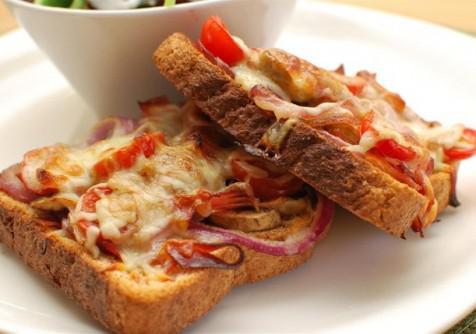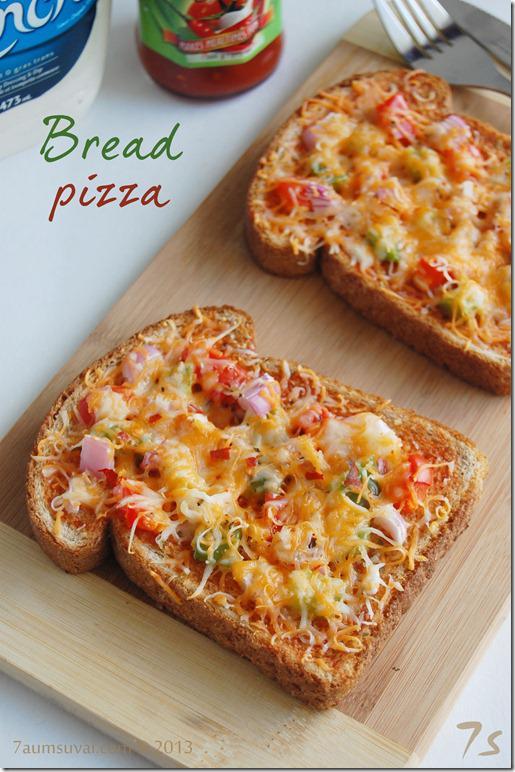The first image is the image on the left, the second image is the image on the right. Evaluate the accuracy of this statement regarding the images: "All pizzas are made on pieces of bread". Is it true? Answer yes or no. Yes. The first image is the image on the left, the second image is the image on the right. Analyze the images presented: Is the assertion "The left image shows a round pizza cut into slices on a wooden board, and the right image shows rectangles of pizza." valid? Answer yes or no. No. 